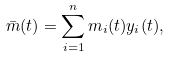Convert formula to latex. <formula><loc_0><loc_0><loc_500><loc_500>\bar { m } ( t ) = \sum _ { i = 1 } ^ { n } m _ { i } ( t ) y _ { i } ( t ) ,</formula> 